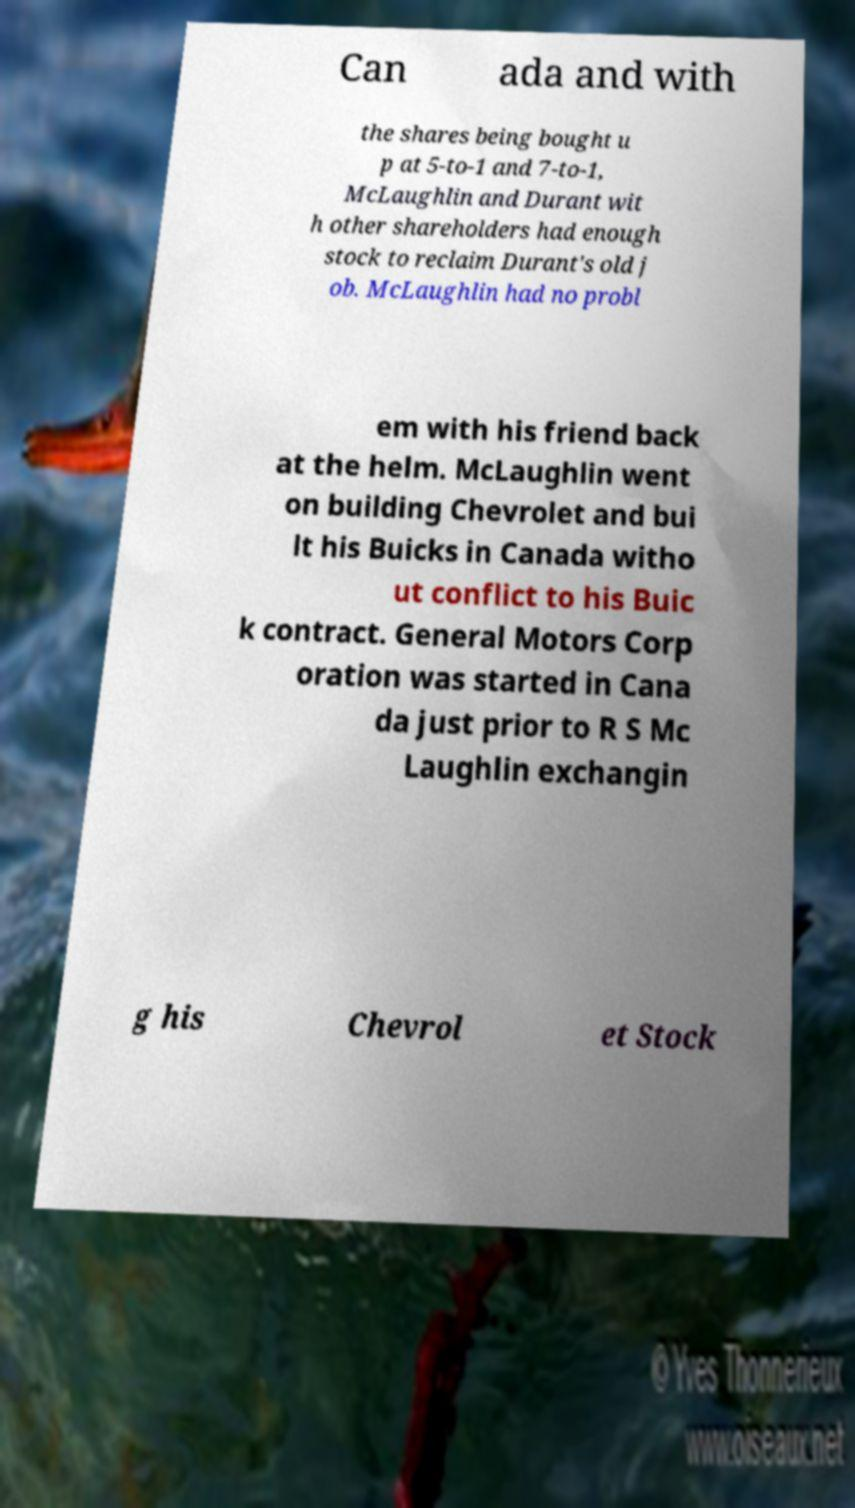Please identify and transcribe the text found in this image. Can ada and with the shares being bought u p at 5-to-1 and 7-to-1, McLaughlin and Durant wit h other shareholders had enough stock to reclaim Durant's old j ob. McLaughlin had no probl em with his friend back at the helm. McLaughlin went on building Chevrolet and bui lt his Buicks in Canada witho ut conflict to his Buic k contract. General Motors Corp oration was started in Cana da just prior to R S Mc Laughlin exchangin g his Chevrol et Stock 